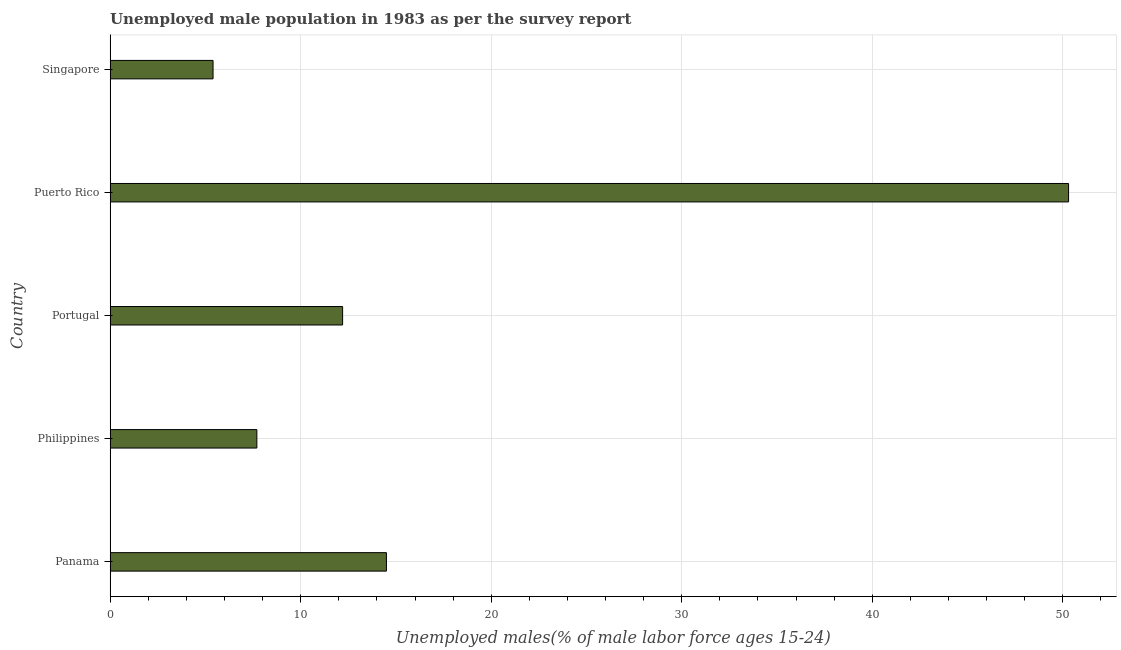Does the graph contain any zero values?
Offer a very short reply. No. What is the title of the graph?
Provide a succinct answer. Unemployed male population in 1983 as per the survey report. What is the label or title of the X-axis?
Your answer should be compact. Unemployed males(% of male labor force ages 15-24). What is the unemployed male youth in Philippines?
Your answer should be compact. 7.7. Across all countries, what is the maximum unemployed male youth?
Your answer should be compact. 50.3. Across all countries, what is the minimum unemployed male youth?
Provide a short and direct response. 5.4. In which country was the unemployed male youth maximum?
Your answer should be very brief. Puerto Rico. In which country was the unemployed male youth minimum?
Offer a very short reply. Singapore. What is the sum of the unemployed male youth?
Provide a short and direct response. 90.1. What is the difference between the unemployed male youth in Philippines and Singapore?
Ensure brevity in your answer.  2.3. What is the average unemployed male youth per country?
Keep it short and to the point. 18.02. What is the median unemployed male youth?
Offer a very short reply. 12.2. What is the ratio of the unemployed male youth in Philippines to that in Puerto Rico?
Ensure brevity in your answer.  0.15. Is the difference between the unemployed male youth in Portugal and Singapore greater than the difference between any two countries?
Ensure brevity in your answer.  No. What is the difference between the highest and the second highest unemployed male youth?
Offer a very short reply. 35.8. What is the difference between the highest and the lowest unemployed male youth?
Ensure brevity in your answer.  44.9. How many countries are there in the graph?
Ensure brevity in your answer.  5. What is the difference between two consecutive major ticks on the X-axis?
Provide a short and direct response. 10. What is the Unemployed males(% of male labor force ages 15-24) in Philippines?
Keep it short and to the point. 7.7. What is the Unemployed males(% of male labor force ages 15-24) in Portugal?
Offer a very short reply. 12.2. What is the Unemployed males(% of male labor force ages 15-24) in Puerto Rico?
Ensure brevity in your answer.  50.3. What is the Unemployed males(% of male labor force ages 15-24) of Singapore?
Your answer should be compact. 5.4. What is the difference between the Unemployed males(% of male labor force ages 15-24) in Panama and Philippines?
Ensure brevity in your answer.  6.8. What is the difference between the Unemployed males(% of male labor force ages 15-24) in Panama and Portugal?
Your response must be concise. 2.3. What is the difference between the Unemployed males(% of male labor force ages 15-24) in Panama and Puerto Rico?
Offer a very short reply. -35.8. What is the difference between the Unemployed males(% of male labor force ages 15-24) in Panama and Singapore?
Offer a terse response. 9.1. What is the difference between the Unemployed males(% of male labor force ages 15-24) in Philippines and Portugal?
Provide a short and direct response. -4.5. What is the difference between the Unemployed males(% of male labor force ages 15-24) in Philippines and Puerto Rico?
Keep it short and to the point. -42.6. What is the difference between the Unemployed males(% of male labor force ages 15-24) in Philippines and Singapore?
Your response must be concise. 2.3. What is the difference between the Unemployed males(% of male labor force ages 15-24) in Portugal and Puerto Rico?
Keep it short and to the point. -38.1. What is the difference between the Unemployed males(% of male labor force ages 15-24) in Portugal and Singapore?
Provide a succinct answer. 6.8. What is the difference between the Unemployed males(% of male labor force ages 15-24) in Puerto Rico and Singapore?
Ensure brevity in your answer.  44.9. What is the ratio of the Unemployed males(% of male labor force ages 15-24) in Panama to that in Philippines?
Make the answer very short. 1.88. What is the ratio of the Unemployed males(% of male labor force ages 15-24) in Panama to that in Portugal?
Provide a succinct answer. 1.19. What is the ratio of the Unemployed males(% of male labor force ages 15-24) in Panama to that in Puerto Rico?
Your answer should be compact. 0.29. What is the ratio of the Unemployed males(% of male labor force ages 15-24) in Panama to that in Singapore?
Make the answer very short. 2.69. What is the ratio of the Unemployed males(% of male labor force ages 15-24) in Philippines to that in Portugal?
Your response must be concise. 0.63. What is the ratio of the Unemployed males(% of male labor force ages 15-24) in Philippines to that in Puerto Rico?
Offer a very short reply. 0.15. What is the ratio of the Unemployed males(% of male labor force ages 15-24) in Philippines to that in Singapore?
Your answer should be very brief. 1.43. What is the ratio of the Unemployed males(% of male labor force ages 15-24) in Portugal to that in Puerto Rico?
Provide a succinct answer. 0.24. What is the ratio of the Unemployed males(% of male labor force ages 15-24) in Portugal to that in Singapore?
Provide a short and direct response. 2.26. What is the ratio of the Unemployed males(% of male labor force ages 15-24) in Puerto Rico to that in Singapore?
Make the answer very short. 9.31. 